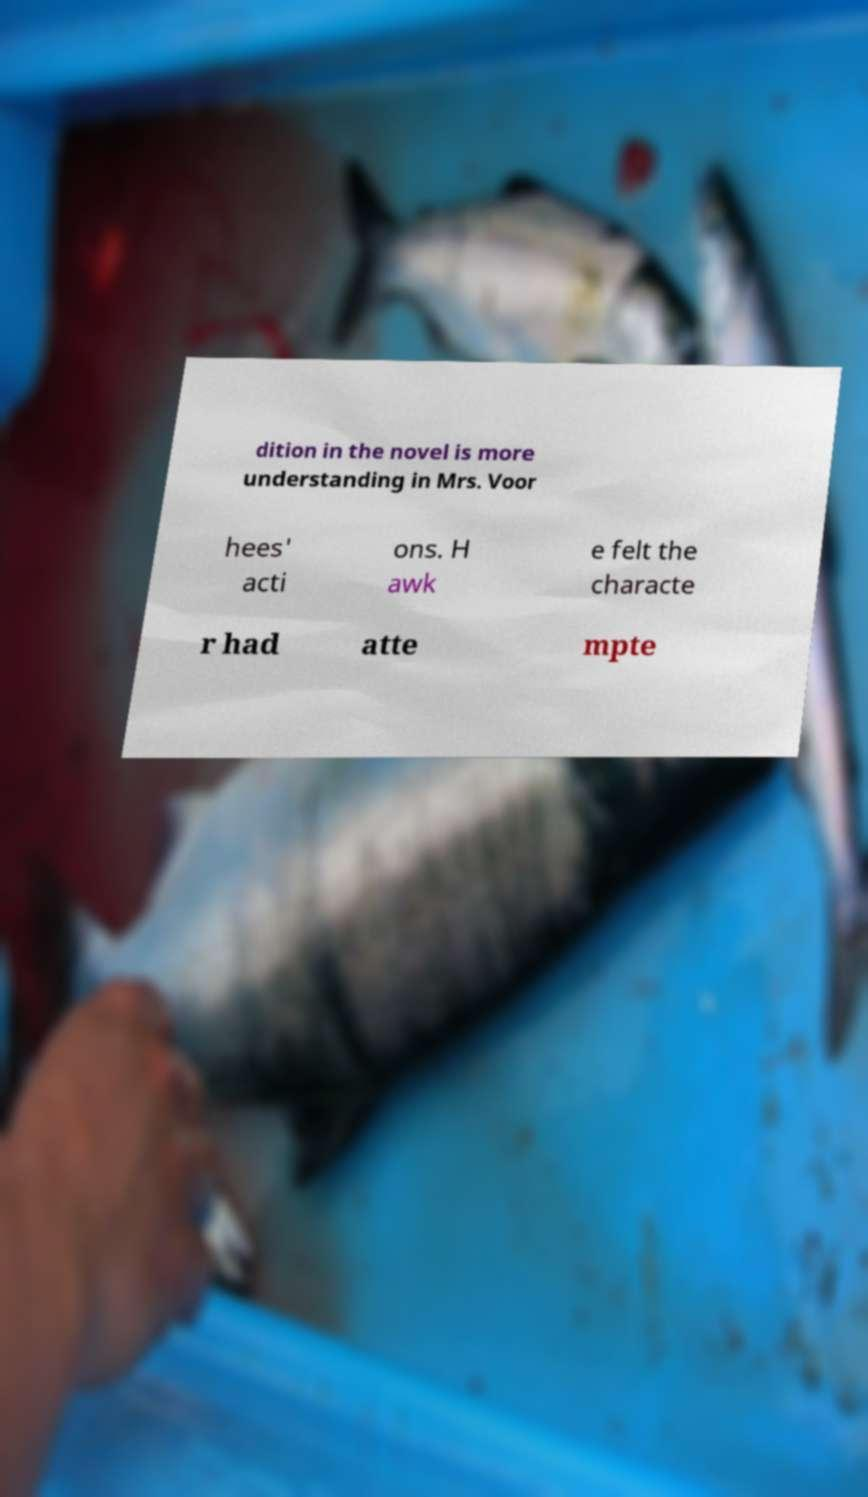There's text embedded in this image that I need extracted. Can you transcribe it verbatim? dition in the novel is more understanding in Mrs. Voor hees' acti ons. H awk e felt the characte r had atte mpte 